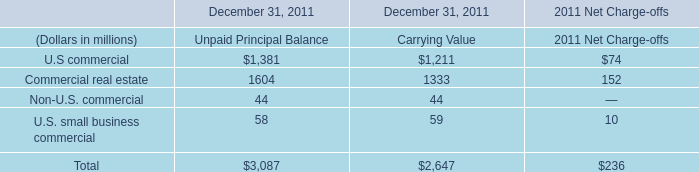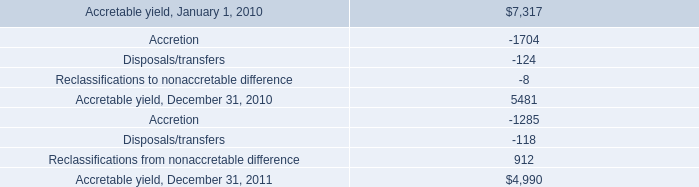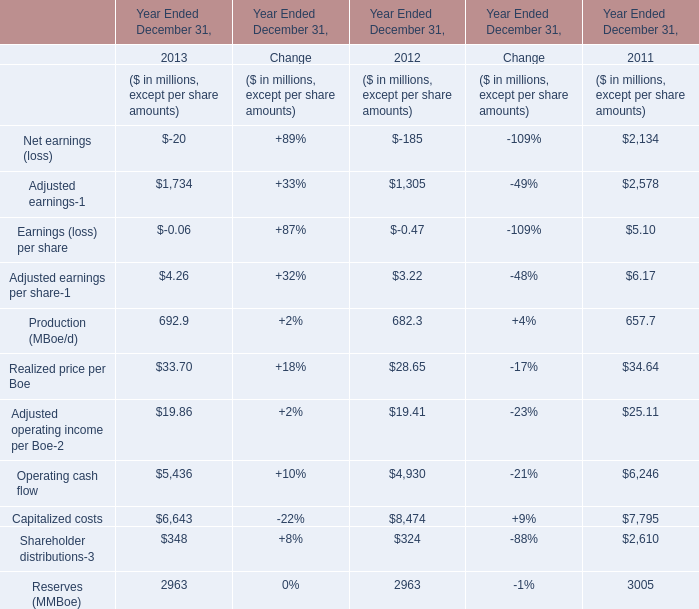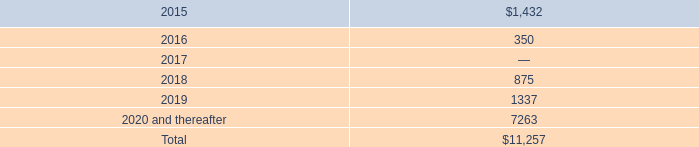In the year with the most Production (MBoe/d), what is the growth rate of Adjusted earnings? 
Computations: ((1734 - 1305) / 1305)
Answer: 0.32874. 